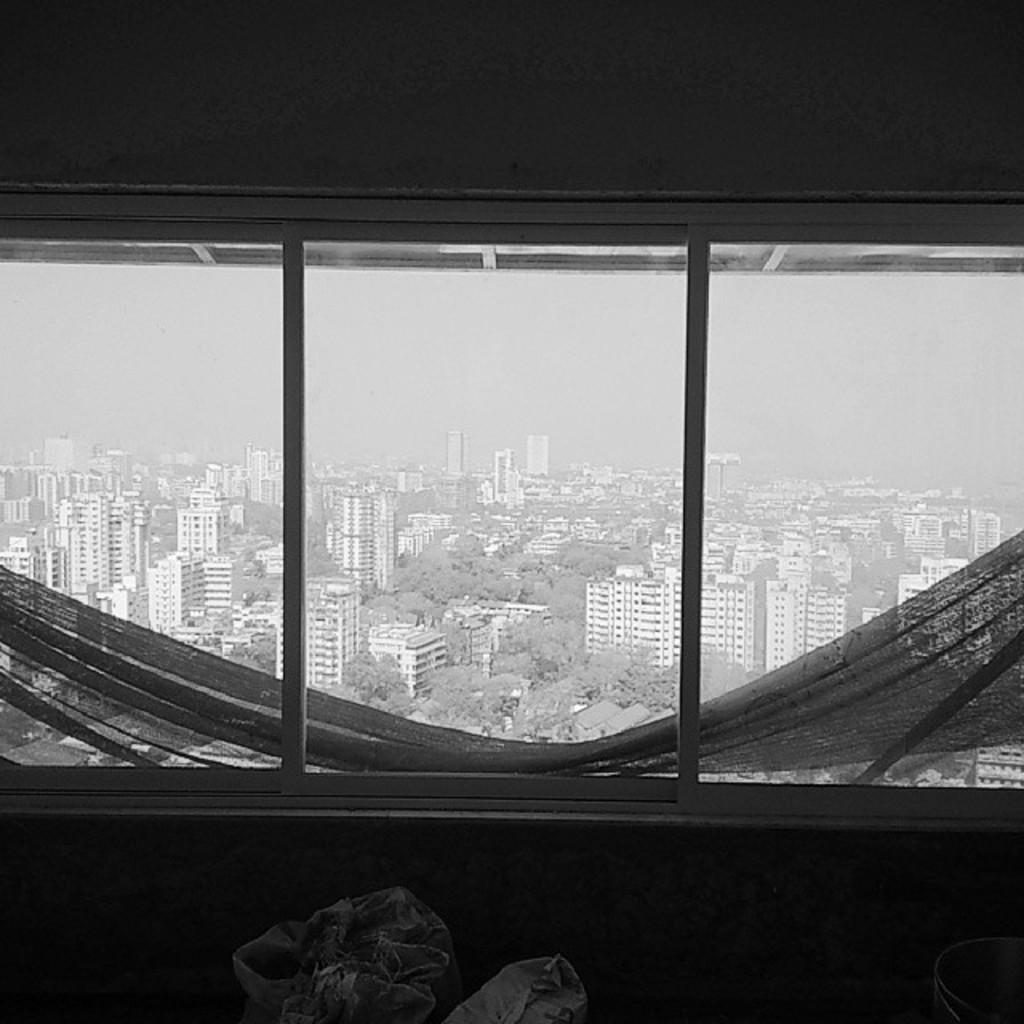What can be seen through the window in the image? Buildings, trees, bags, cloth, and the sky are visible through the window in the image. What is located near the window in the image? There is a wall in the image. Can you describe the window in the image? There is a window in the image. What type of pencil is being used by the servant in the image? There is no servant or pencil present in the image. What type of prose is being written on the cloth visible through the window? There is no writing or prose visible on the cloth in the image. 